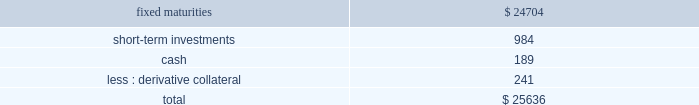Hlikk has four revolving credit facilities in support of operations .
Two of the credit facilities have no amounts drawn as of december 31 , 2013 with borrowing limits of approximately a55 billion , or $ 48 each , and individually have expiration dates of january 5 , 2015 and september 30 , 2014 .
In december 2013 , hlikk entered into two new revolving credit facility agreements with two japanese banks in order to finance certain withholding taxes on mutual fund gains , that are subsequently credited when hlikk files its 2019 income tax returns .
At december 31 , 2013 , hlikk had drawn the total borrowing limits of a55 billion , or $ 48 , and a520 billion , or $ 190 on these credit facilities .
The a55 billion credit facility accrues interest at a variable rate based on the one month tokyo interbank offering rate ( tibor ) plus 3 bps , which as of december 31 , 2013 the interest rate was 15 bps , and the a520 billion credit facility accrues interest at a variable rate based on tibor plus 3 bps , or the actual cost of funding , which as of december 31 , 2013 the interest rate was 20 bps .
Both of the credit facilities expire on september 30 , 2014 .
Derivative commitments certain of the company 2019s derivative agreements contain provisions that are tied to the financial strength ratings of the individual legal entity that entered into the derivative agreement as set by nationally recognized statistical rating agencies .
If the legal entity 2019s financial strength were to fall below certain ratings , the counterparties to the derivative agreements could demand immediate and ongoing full collateralization and in certain instances demand immediate settlement of all outstanding derivative positions traded under each impacted bilateral agreement .
The settlement amount is determined by netting the derivative positions transacted under each agreement .
If the termination rights were to be exercised by the counterparties , it could impact the legal entity 2019s ability to conduct hedging activities by increasing the associated costs and decreasing the willingness of counterparties to transact with the legal entity .
The aggregate fair value of all derivative instruments with credit-risk-related contingent features that are in a net liability position as of december 31 , 2013 was $ 1.2 billion .
Of this $ 1.2 billion the legal entities have posted collateral of $ 1.4 billion in the normal course of business .
In addition , the company has posted collateral of $ 44 associated with a customized gmwb derivative .
Based on derivative market values as of december 31 , 2013 , a downgrade of one level below the current financial strength ratings by either moody 2019s or s&p could require approximately an additional $ 12 to be posted as collateral .
Based on derivative market values as of december 31 , 2013 , a downgrade by either moody 2019s or s&p of two levels below the legal entities 2019 current financial strength ratings could require approximately an additional $ 33 of assets to be posted as collateral .
These collateral amounts could change as derivative market values change , as a result of changes in our hedging activities or to the extent changes in contractual terms are negotiated .
The nature of the collateral that we would post , if required , would be primarily in the form of u.s .
Treasury bills , u.s .
Treasury notes and government agency securities .
As of december 31 , 2013 , the aggregate notional amount and fair value of derivative relationships that could be subject to immediate termination in the event of rating agency downgrades to either bbb+ or baa1 was $ 536 and $ ( 17 ) , respectively .
Insurance operations current and expected patterns of claim frequency and severity or surrenders may change from period to period but continue to be within historical norms and , therefore , the company 2019s insurance operations 2019 current liquidity position is considered to be sufficient to meet anticipated demands over the next twelve months , including any obligations related to the company 2019s restructuring activities .
For a discussion and tabular presentation of the company 2019s current contractual obligations by period , refer to off-balance sheet arrangements and aggregate contractual obligations within the capital resources and liquidity section of the md&a .
The principal sources of operating funds are premiums , fees earned from assets under management and investment income , while investing cash flows originate from maturities and sales of invested assets .
The primary uses of funds are to pay claims , claim adjustment expenses , commissions and other underwriting expenses , to purchase new investments and to make dividend payments to the hfsg holding company .
The company 2019s insurance operations consist of property and casualty insurance products ( collectively referred to as 201cproperty & casualty operations 201d ) and life insurance and legacy annuity products ( collectively referred to as 201clife operations 201d ) .
Property & casualty operations property & casualty operations holds fixed maturity securities including a significant short-term investment position ( securities with maturities of one year or less at the time of purchase ) to meet liquidity needs .
As of december 31 , 2013 , property & casualty operations 2019 fixed maturities , short-term investments , and cash are summarized as follows: .

As of december 31 , 2013 , what was the percent of the total property & casualty operations 2019 from short-term investments? 
Computations: (984 / 25636)
Answer: 0.03838. 